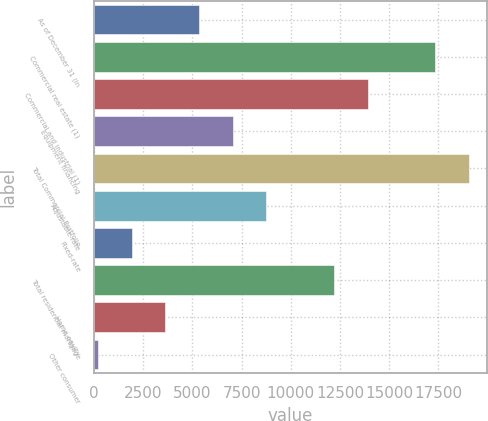Convert chart. <chart><loc_0><loc_0><loc_500><loc_500><bar_chart><fcel>As of December 31 (in<fcel>Commercial real estate (1)<fcel>Commercial and industrial (1)<fcel>Equipment financing<fcel>Total Commercial Portfolio<fcel>Adjustable-rate<fcel>Fixed-rate<fcel>Total residential mortgage<fcel>Home equity<fcel>Other consumer<nl><fcel>5337.58<fcel>17322.7<fcel>13898.4<fcel>7049.74<fcel>19034.9<fcel>8761.9<fcel>1913.26<fcel>12186.2<fcel>3625.42<fcel>201.1<nl></chart> 